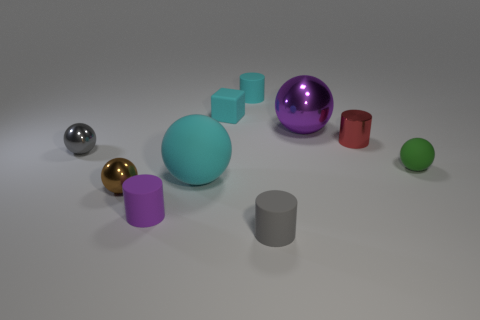What shape is the big thing that is the same material as the small brown object?
Offer a very short reply. Sphere. What number of tiny gray matte cylinders are right of the tiny matte object right of the red shiny cylinder?
Your answer should be very brief. 0. What number of small rubber objects are in front of the tiny cyan cylinder and behind the tiny red cylinder?
Your response must be concise. 1. How many other things are made of the same material as the green sphere?
Provide a short and direct response. 5. What is the color of the small ball right of the small matte cylinder that is on the left side of the big matte object?
Your answer should be compact. Green. Does the tiny metal object that is on the right side of the large purple thing have the same color as the big matte sphere?
Ensure brevity in your answer.  No. Is the size of the brown object the same as the gray shiny sphere?
Your response must be concise. Yes. There is a purple shiny thing that is the same size as the cyan rubber ball; what is its shape?
Ensure brevity in your answer.  Sphere. There is a ball that is on the right side of the red object; does it have the same size as the brown ball?
Provide a succinct answer. Yes. There is a brown thing that is the same size as the green rubber thing; what is it made of?
Your answer should be very brief. Metal. 